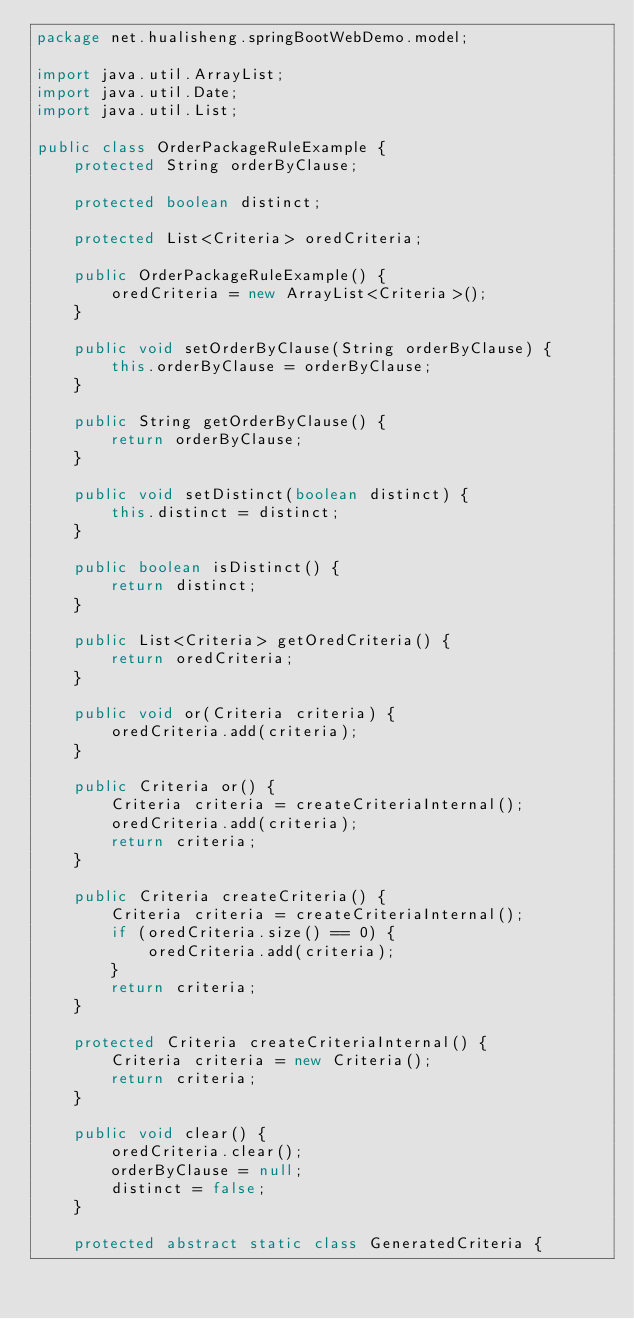Convert code to text. <code><loc_0><loc_0><loc_500><loc_500><_Java_>package net.hualisheng.springBootWebDemo.model;

import java.util.ArrayList;
import java.util.Date;
import java.util.List;

public class OrderPackageRuleExample {
    protected String orderByClause;

    protected boolean distinct;

    protected List<Criteria> oredCriteria;

    public OrderPackageRuleExample() {
        oredCriteria = new ArrayList<Criteria>();
    }

    public void setOrderByClause(String orderByClause) {
        this.orderByClause = orderByClause;
    }

    public String getOrderByClause() {
        return orderByClause;
    }

    public void setDistinct(boolean distinct) {
        this.distinct = distinct;
    }

    public boolean isDistinct() {
        return distinct;
    }

    public List<Criteria> getOredCriteria() {
        return oredCriteria;
    }

    public void or(Criteria criteria) {
        oredCriteria.add(criteria);
    }

    public Criteria or() {
        Criteria criteria = createCriteriaInternal();
        oredCriteria.add(criteria);
        return criteria;
    }

    public Criteria createCriteria() {
        Criteria criteria = createCriteriaInternal();
        if (oredCriteria.size() == 0) {
            oredCriteria.add(criteria);
        }
        return criteria;
    }

    protected Criteria createCriteriaInternal() {
        Criteria criteria = new Criteria();
        return criteria;
    }

    public void clear() {
        oredCriteria.clear();
        orderByClause = null;
        distinct = false;
    }

    protected abstract static class GeneratedCriteria {</code> 